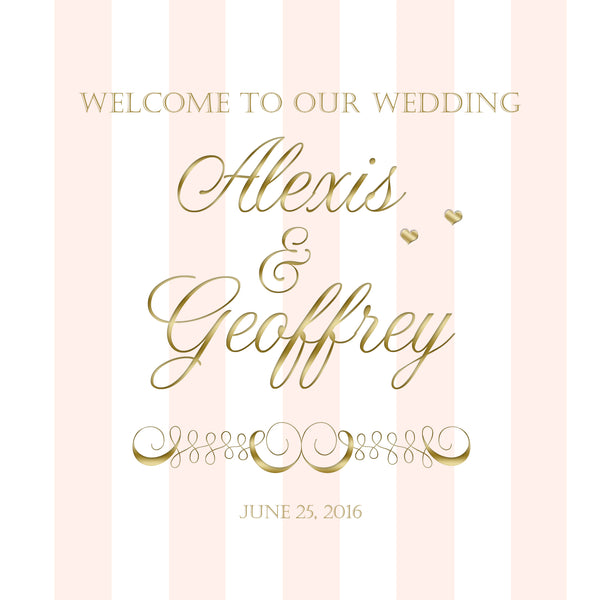If this wedding invitation were part of a fairytale, what magical elements might be included in the wedding? In a fairytale setting, this wedding could take place in a grand enchanted castle surrounded by lush gardens. Golden carriages pulled by white horses would transport the bride and groom. The evening would be illuminated by floating lanterns, and mythical creatures like fairies and unicorns might make an appearance. The ceremony could include a magical vow exchange under an archway of flowers that shimmer with every touch, and the reception might have a ballroom where guests dance to music played by enchanted instruments. 